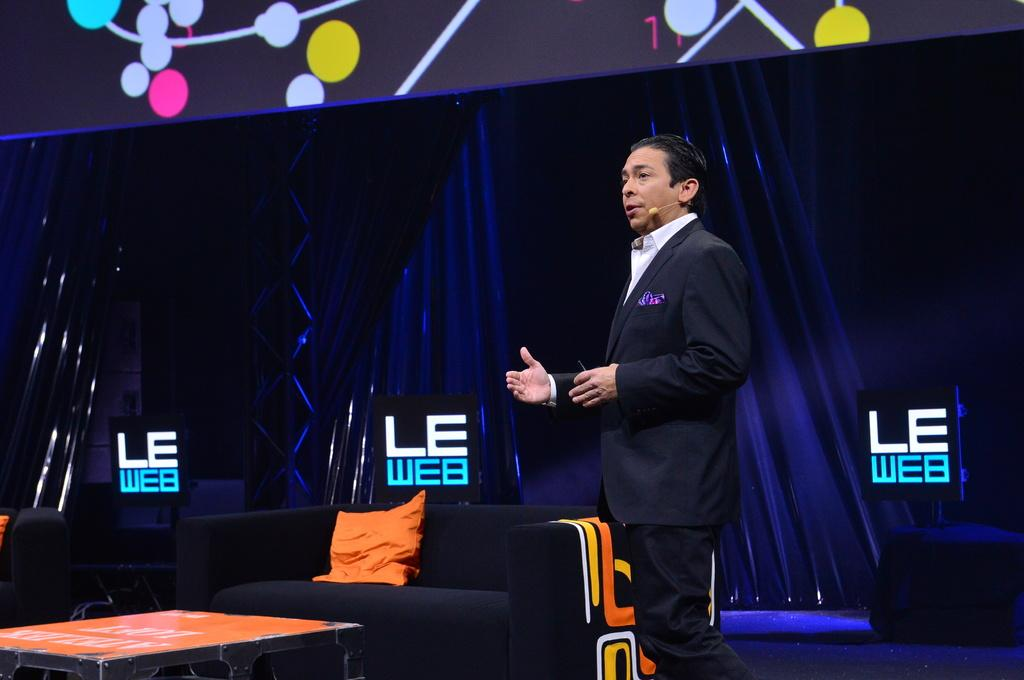<image>
Give a short and clear explanation of the subsequent image. A man wearing a suit stands in front of two signs that read LE WEB 